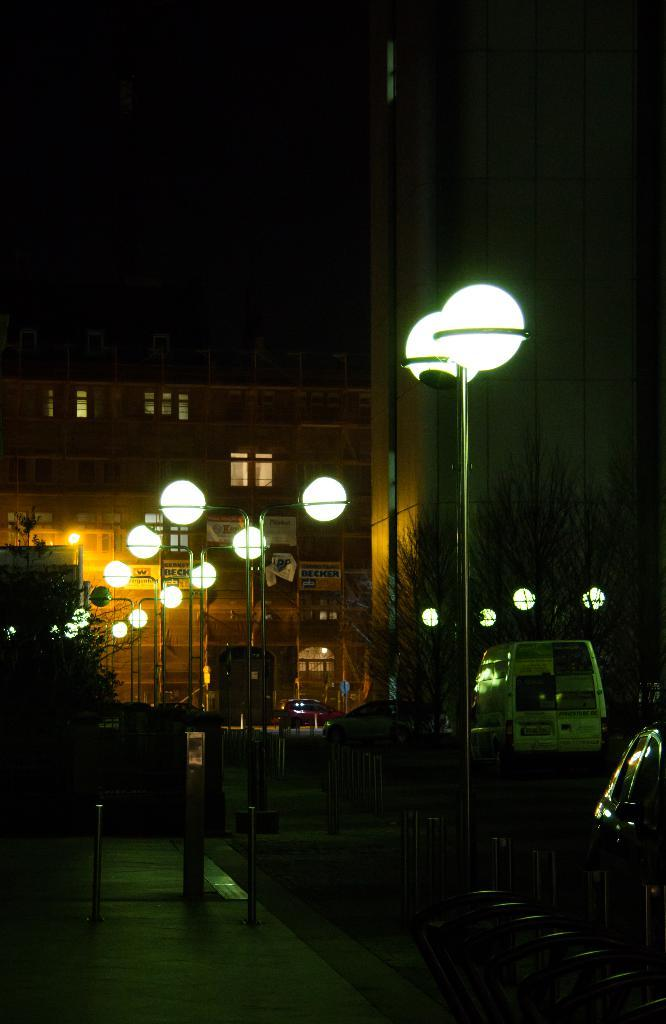What can be seen on the road side in the image? There are lamp posts on the road side in the image. What is the condition of the parked vehicles in the image? Some cars are parked in the image. What type of building can be seen in the background? There is a brown color building in the background. What type of meat is being prepared on the plough in the image? There is no meat or plough present in the image; it features lamp posts, parked cars, and a brown building. 